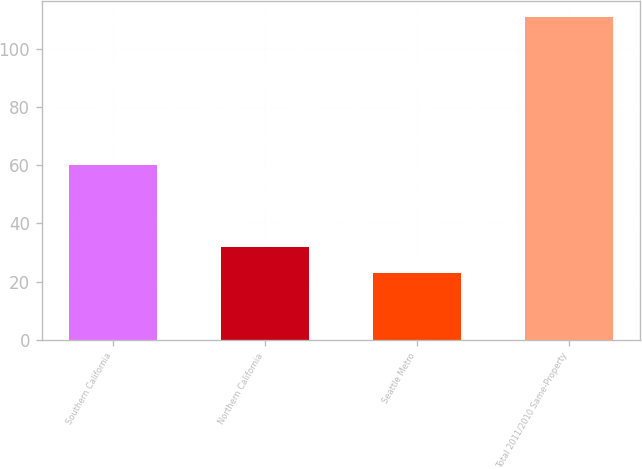Convert chart. <chart><loc_0><loc_0><loc_500><loc_500><bar_chart><fcel>Southern California<fcel>Northern California<fcel>Seattle Metro<fcel>Total 2011/2010 Same-Property<nl><fcel>60<fcel>31.8<fcel>23<fcel>111<nl></chart> 